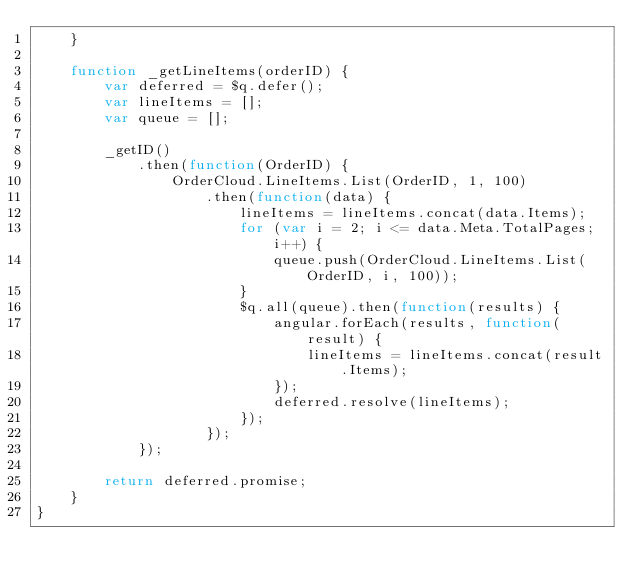Convert code to text. <code><loc_0><loc_0><loc_500><loc_500><_JavaScript_>    }

    function _getLineItems(orderID) {
        var deferred = $q.defer();
        var lineItems = [];
        var queue = [];

        _getID()
            .then(function(OrderID) {
                OrderCloud.LineItems.List(OrderID, 1, 100)
                    .then(function(data) {
                        lineItems = lineItems.concat(data.Items);
                        for (var i = 2; i <= data.Meta.TotalPages; i++) {
                            queue.push(OrderCloud.LineItems.List(OrderID, i, 100));
                        }
                        $q.all(queue).then(function(results) {
                            angular.forEach(results, function(result) {
                                lineItems = lineItems.concat(result.Items);
                            });
                            deferred.resolve(lineItems);
                        });
                    });
            });

        return deferred.promise;
    }
}</code> 